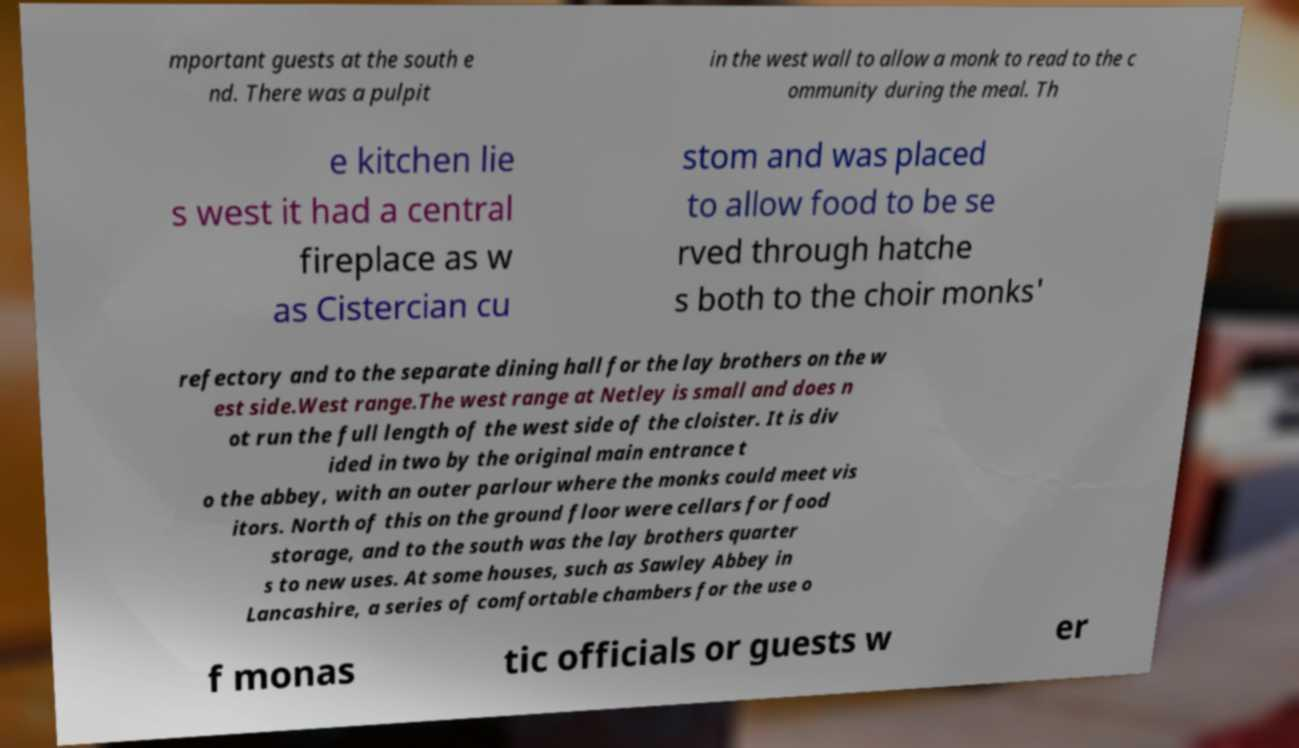Please read and relay the text visible in this image. What does it say? mportant guests at the south e nd. There was a pulpit in the west wall to allow a monk to read to the c ommunity during the meal. Th e kitchen lie s west it had a central fireplace as w as Cistercian cu stom and was placed to allow food to be se rved through hatche s both to the choir monks' refectory and to the separate dining hall for the lay brothers on the w est side.West range.The west range at Netley is small and does n ot run the full length of the west side of the cloister. It is div ided in two by the original main entrance t o the abbey, with an outer parlour where the monks could meet vis itors. North of this on the ground floor were cellars for food storage, and to the south was the lay brothers quarter s to new uses. At some houses, such as Sawley Abbey in Lancashire, a series of comfortable chambers for the use o f monas tic officials or guests w er 